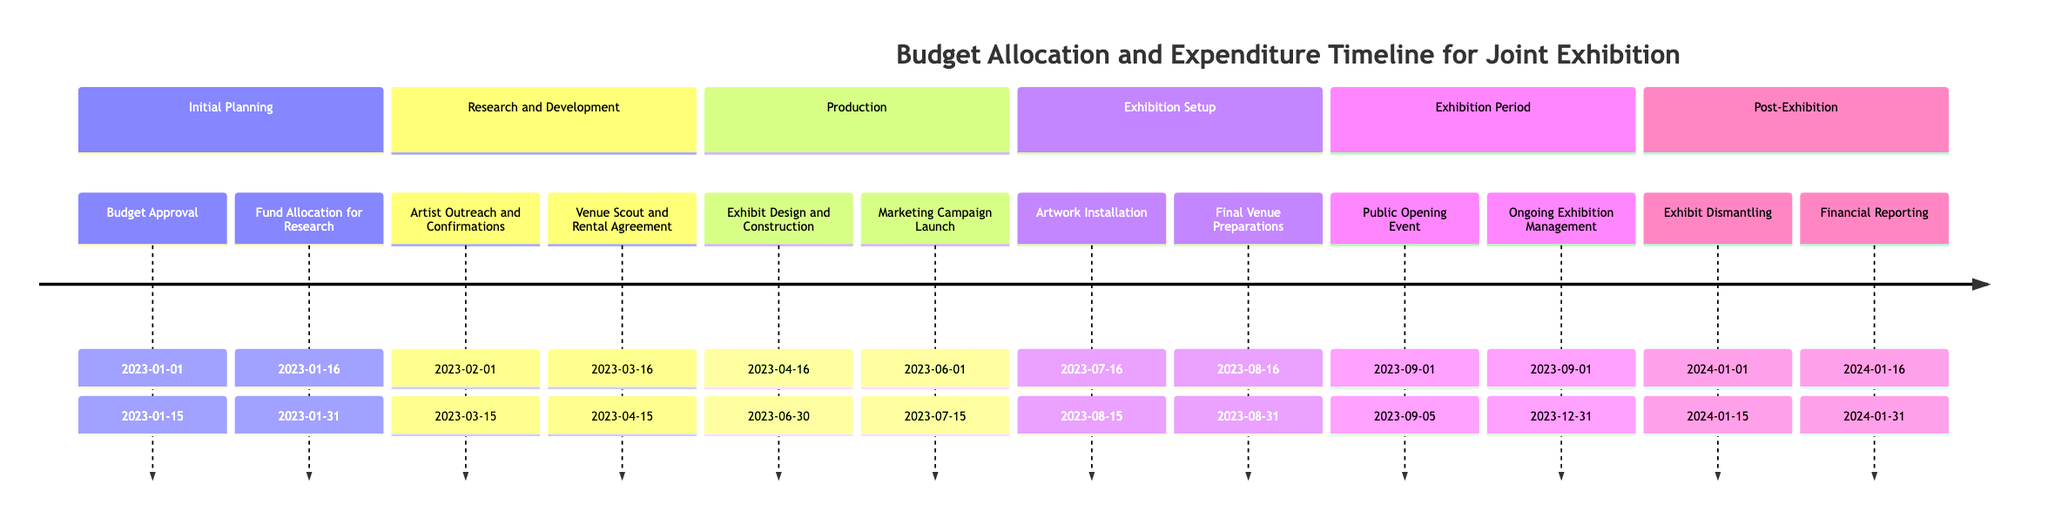What is the total budget allocated during the Research and Development phase? The Research and Development phase has a total budget allocated of 150000. This is specified directly in the timeline for that particular phase.
Answer: 150000 Who is responsible for the Marketing Campaign Launch activity? The responsible entity for the Marketing Campaign Launch activity is the Marketing Department, as stated in the activity details within the Production phase.
Answer: Marketing Department How much budget was spent in the Exhibition Setup phase? In the Exhibition Setup phase, the budget spent amounts to 50000, which is clearly indicated in the budget details for that phase.
Answer: 50000 During which dates does the Artist Outreach and Confirmations activity take place? The Artist Outreach and Confirmations activity takes place from February 1, 2023, to March 15, 2023, as shown in the timeline under the Research and Development section.
Answer: February 1, 2023 to March 15, 2023 What is the total budget allocated for the entire project? To find the total budget allocated, we sum the budgets from all phases: 50000 + 150000 + 200000 + 100000 + 50000 + 25000, which equals 525000. This value is derived from adding up each phase's allocated budget shown in the timeline.
Answer: 525000 What is the end date for the Financial Reporting activity? The Financial Reporting activity ends on January 31, 2024, as indicated in the timeline within the Post-Exhibition phase.
Answer: January 31, 2024 Which activity is responsible for the ongoing management of the exhibition? The Ongoing Exhibition Management activity is responsible for this task, as stated in the timeline under the Exhibition Period phase.
Answer: Ongoing Exhibition Management How much budget remains unspent after the Production phase? After the Production phase, the budget spent is 100000 out of 200000 allocated, leaving 100000 unspent (200000 - 100000). This calculation is done by subtracting the spent amount from the allocated budget in that phase.
Answer: 100000 What is the date range for the Public Opening Event? The Public Opening Event occurs from September 1, 2023, to September 5, 2023, as outlined in the timeline within the Exhibition Period phase.
Answer: September 1, 2023 to September 5, 2023 